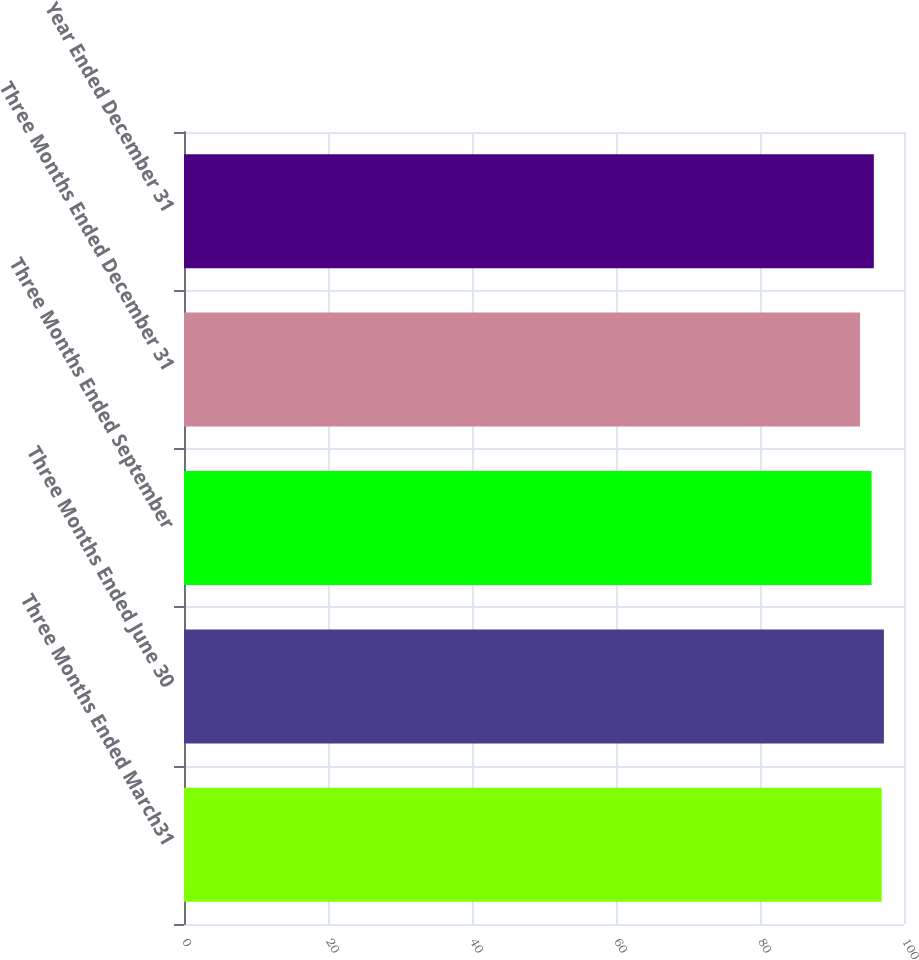Convert chart. <chart><loc_0><loc_0><loc_500><loc_500><bar_chart><fcel>Three Months Ended March31<fcel>Three Months Ended June 30<fcel>Three Months Ended September<fcel>Three Months Ended December 31<fcel>Year Ended December 31<nl><fcel>96.9<fcel>97.21<fcel>95.5<fcel>93.9<fcel>95.81<nl></chart> 